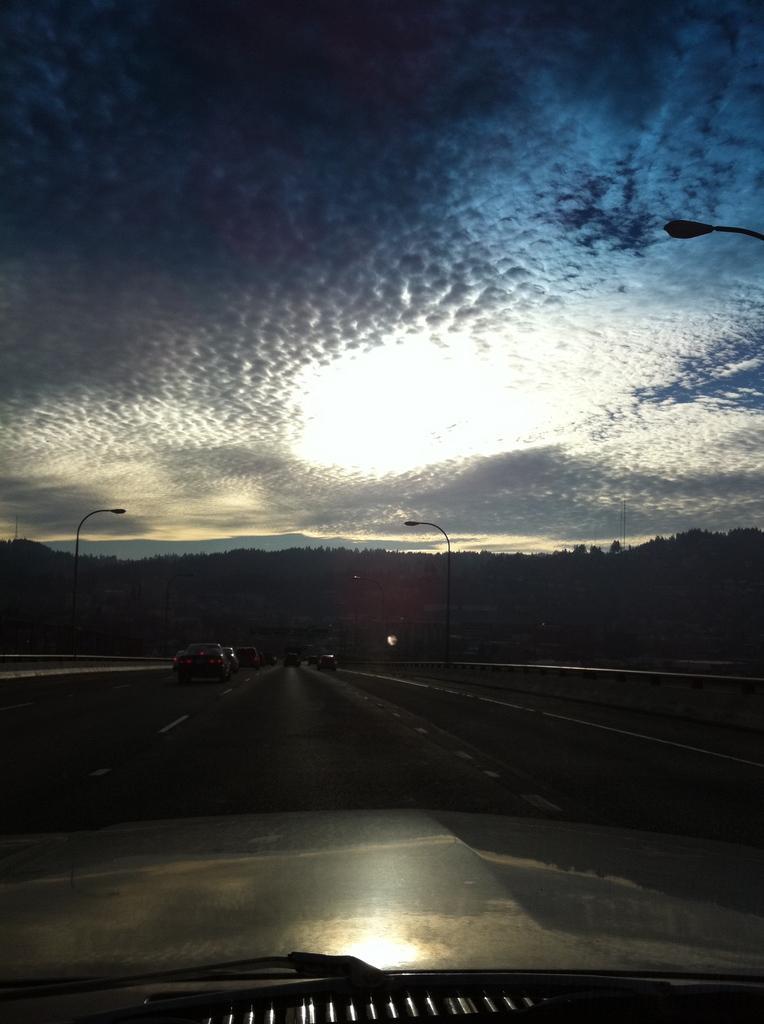In one or two sentences, can you explain what this image depicts? In this picture, it seems like a car in the foreground, there are vehicles, poles, trees and the sky in the background. 